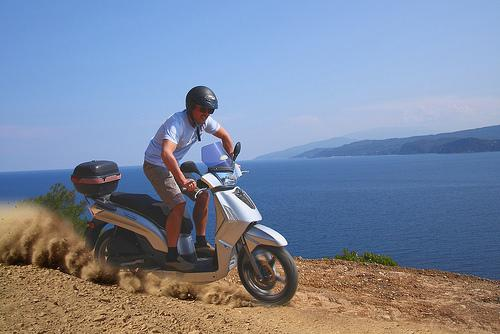Question: what is the man doing?
Choices:
A. Driving a dirt bike.
B. Singing.
C. Dancing.
D. Starring in a broadway musical.
Answer with the letter. Answer: A Question: how was this picture taken?
Choices:
A. Ipad.
B. Ipod.
C. Phone.
D. Camera.
Answer with the letter. Answer: D Question: where was this picture taken?
Choices:
A. On the ski slope.
B. In the jungle.
C. At the lake.
D. In the desert.
Answer with the letter. Answer: C 